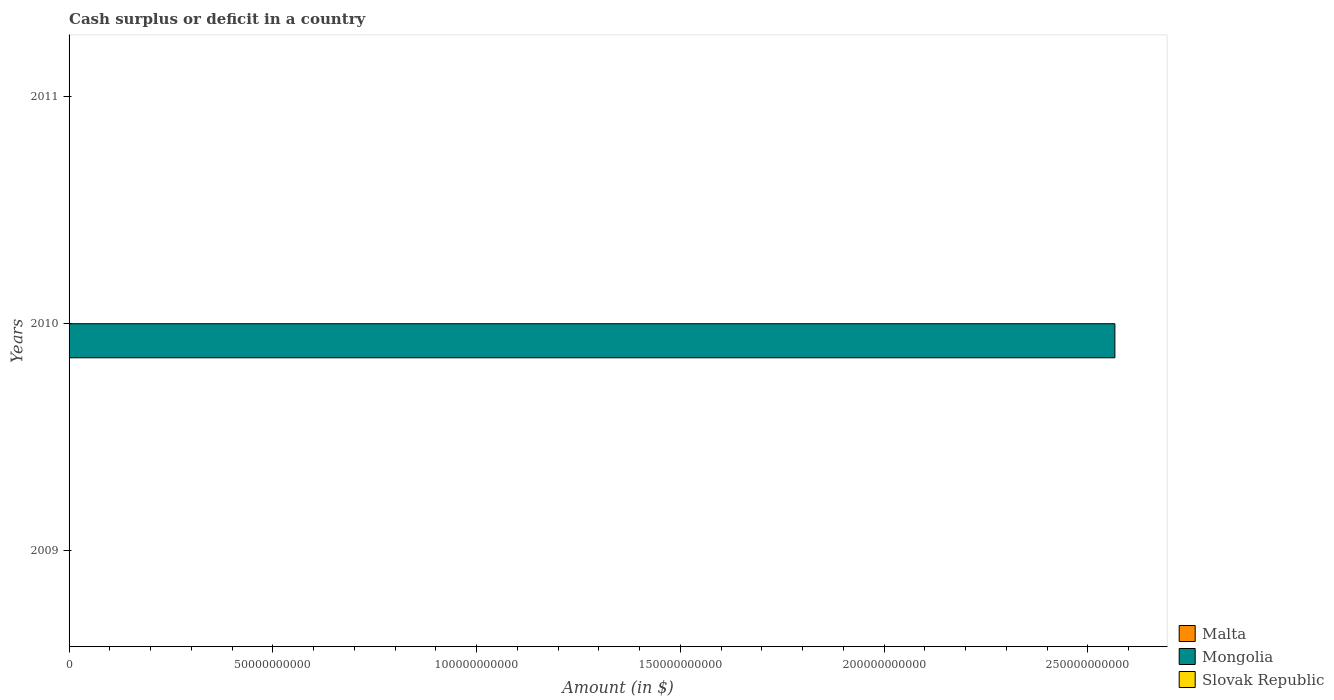Are the number of bars per tick equal to the number of legend labels?
Give a very brief answer. No. How many bars are there on the 1st tick from the top?
Give a very brief answer. 0. What is the label of the 3rd group of bars from the top?
Make the answer very short. 2009. In how many cases, is the number of bars for a given year not equal to the number of legend labels?
Your answer should be compact. 3. What is the amount of cash surplus or deficit in Malta in 2009?
Your answer should be compact. 0. Across all years, what is the maximum amount of cash surplus or deficit in Mongolia?
Offer a very short reply. 2.57e+11. Across all years, what is the minimum amount of cash surplus or deficit in Slovak Republic?
Make the answer very short. 0. What is the average amount of cash surplus or deficit in Mongolia per year?
Your answer should be compact. 8.55e+1. How many bars are there?
Offer a terse response. 1. Are all the bars in the graph horizontal?
Your response must be concise. Yes. How many years are there in the graph?
Keep it short and to the point. 3. What is the difference between two consecutive major ticks on the X-axis?
Offer a terse response. 5.00e+1. Are the values on the major ticks of X-axis written in scientific E-notation?
Your answer should be compact. No. Does the graph contain grids?
Provide a short and direct response. No. Where does the legend appear in the graph?
Offer a terse response. Bottom right. How are the legend labels stacked?
Your answer should be very brief. Vertical. What is the title of the graph?
Provide a succinct answer. Cash surplus or deficit in a country. What is the label or title of the X-axis?
Make the answer very short. Amount (in $). What is the Amount (in $) of Mongolia in 2010?
Keep it short and to the point. 2.57e+11. What is the Amount (in $) of Slovak Republic in 2011?
Offer a very short reply. 0. Across all years, what is the maximum Amount (in $) of Mongolia?
Give a very brief answer. 2.57e+11. Across all years, what is the minimum Amount (in $) in Mongolia?
Offer a very short reply. 0. What is the total Amount (in $) of Malta in the graph?
Provide a short and direct response. 0. What is the total Amount (in $) in Mongolia in the graph?
Make the answer very short. 2.57e+11. What is the average Amount (in $) of Malta per year?
Your response must be concise. 0. What is the average Amount (in $) in Mongolia per year?
Your answer should be compact. 8.55e+1. What is the difference between the highest and the lowest Amount (in $) of Mongolia?
Give a very brief answer. 2.57e+11. 